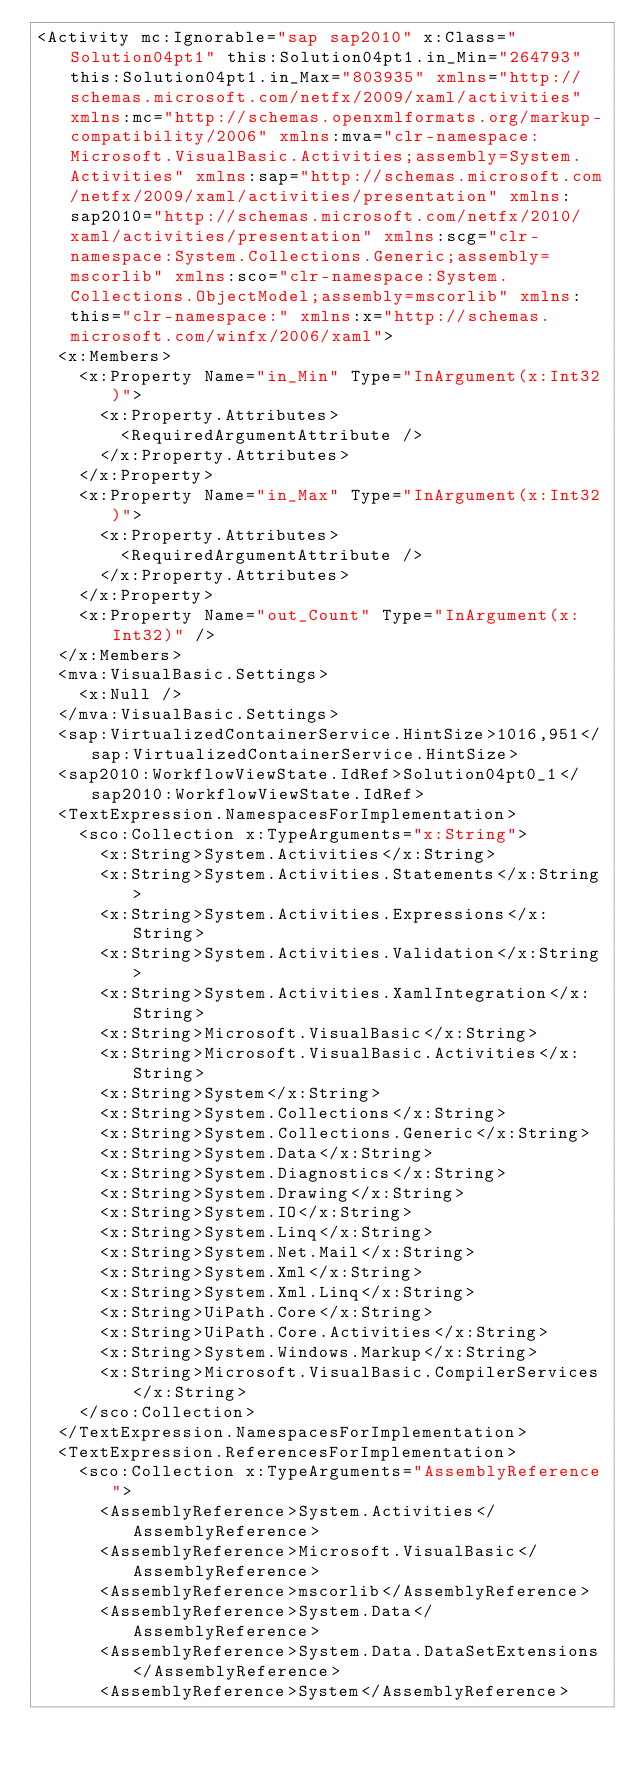Convert code to text. <code><loc_0><loc_0><loc_500><loc_500><_XML_><Activity mc:Ignorable="sap sap2010" x:Class="Solution04pt1" this:Solution04pt1.in_Min="264793" this:Solution04pt1.in_Max="803935" xmlns="http://schemas.microsoft.com/netfx/2009/xaml/activities" xmlns:mc="http://schemas.openxmlformats.org/markup-compatibility/2006" xmlns:mva="clr-namespace:Microsoft.VisualBasic.Activities;assembly=System.Activities" xmlns:sap="http://schemas.microsoft.com/netfx/2009/xaml/activities/presentation" xmlns:sap2010="http://schemas.microsoft.com/netfx/2010/xaml/activities/presentation" xmlns:scg="clr-namespace:System.Collections.Generic;assembly=mscorlib" xmlns:sco="clr-namespace:System.Collections.ObjectModel;assembly=mscorlib" xmlns:this="clr-namespace:" xmlns:x="http://schemas.microsoft.com/winfx/2006/xaml">
  <x:Members>
    <x:Property Name="in_Min" Type="InArgument(x:Int32)">
      <x:Property.Attributes>
        <RequiredArgumentAttribute />
      </x:Property.Attributes>
    </x:Property>
    <x:Property Name="in_Max" Type="InArgument(x:Int32)">
      <x:Property.Attributes>
        <RequiredArgumentAttribute />
      </x:Property.Attributes>
    </x:Property>
    <x:Property Name="out_Count" Type="InArgument(x:Int32)" />
  </x:Members>
  <mva:VisualBasic.Settings>
    <x:Null />
  </mva:VisualBasic.Settings>
  <sap:VirtualizedContainerService.HintSize>1016,951</sap:VirtualizedContainerService.HintSize>
  <sap2010:WorkflowViewState.IdRef>Solution04pt0_1</sap2010:WorkflowViewState.IdRef>
  <TextExpression.NamespacesForImplementation>
    <sco:Collection x:TypeArguments="x:String">
      <x:String>System.Activities</x:String>
      <x:String>System.Activities.Statements</x:String>
      <x:String>System.Activities.Expressions</x:String>
      <x:String>System.Activities.Validation</x:String>
      <x:String>System.Activities.XamlIntegration</x:String>
      <x:String>Microsoft.VisualBasic</x:String>
      <x:String>Microsoft.VisualBasic.Activities</x:String>
      <x:String>System</x:String>
      <x:String>System.Collections</x:String>
      <x:String>System.Collections.Generic</x:String>
      <x:String>System.Data</x:String>
      <x:String>System.Diagnostics</x:String>
      <x:String>System.Drawing</x:String>
      <x:String>System.IO</x:String>
      <x:String>System.Linq</x:String>
      <x:String>System.Net.Mail</x:String>
      <x:String>System.Xml</x:String>
      <x:String>System.Xml.Linq</x:String>
      <x:String>UiPath.Core</x:String>
      <x:String>UiPath.Core.Activities</x:String>
      <x:String>System.Windows.Markup</x:String>
      <x:String>Microsoft.VisualBasic.CompilerServices</x:String>
    </sco:Collection>
  </TextExpression.NamespacesForImplementation>
  <TextExpression.ReferencesForImplementation>
    <sco:Collection x:TypeArguments="AssemblyReference">
      <AssemblyReference>System.Activities</AssemblyReference>
      <AssemblyReference>Microsoft.VisualBasic</AssemblyReference>
      <AssemblyReference>mscorlib</AssemblyReference>
      <AssemblyReference>System.Data</AssemblyReference>
      <AssemblyReference>System.Data.DataSetExtensions</AssemblyReference>
      <AssemblyReference>System</AssemblyReference></code> 